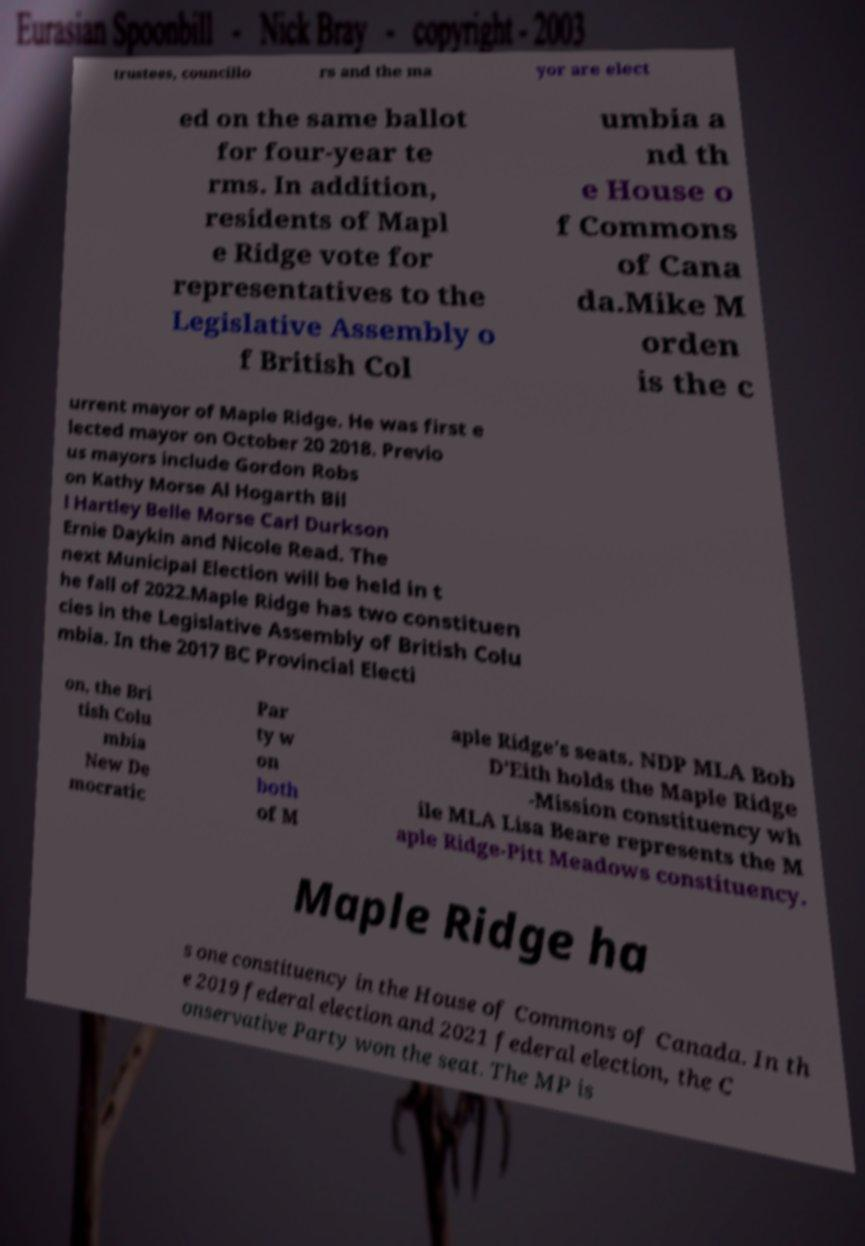For documentation purposes, I need the text within this image transcribed. Could you provide that? trustees, councillo rs and the ma yor are elect ed on the same ballot for four-year te rms. In addition, residents of Mapl e Ridge vote for representatives to the Legislative Assembly o f British Col umbia a nd th e House o f Commons of Cana da.Mike M orden is the c urrent mayor of Maple Ridge. He was first e lected mayor on October 20 2018. Previo us mayors include Gordon Robs on Kathy Morse Al Hogarth Bil l Hartley Belle Morse Carl Durkson Ernie Daykin and Nicole Read. The next Municipal Election will be held in t he fall of 2022.Maple Ridge has two constituen cies in the Legislative Assembly of British Colu mbia. In the 2017 BC Provincial Electi on, the Bri tish Colu mbia New De mocratic Par ty w on both of M aple Ridge's seats. NDP MLA Bob D'Eith holds the Maple Ridge -Mission constituency wh ile MLA Lisa Beare represents the M aple Ridge-Pitt Meadows constituency. Maple Ridge ha s one constituency in the House of Commons of Canada. In th e 2019 federal election and 2021 federal election, the C onservative Party won the seat. The MP is 